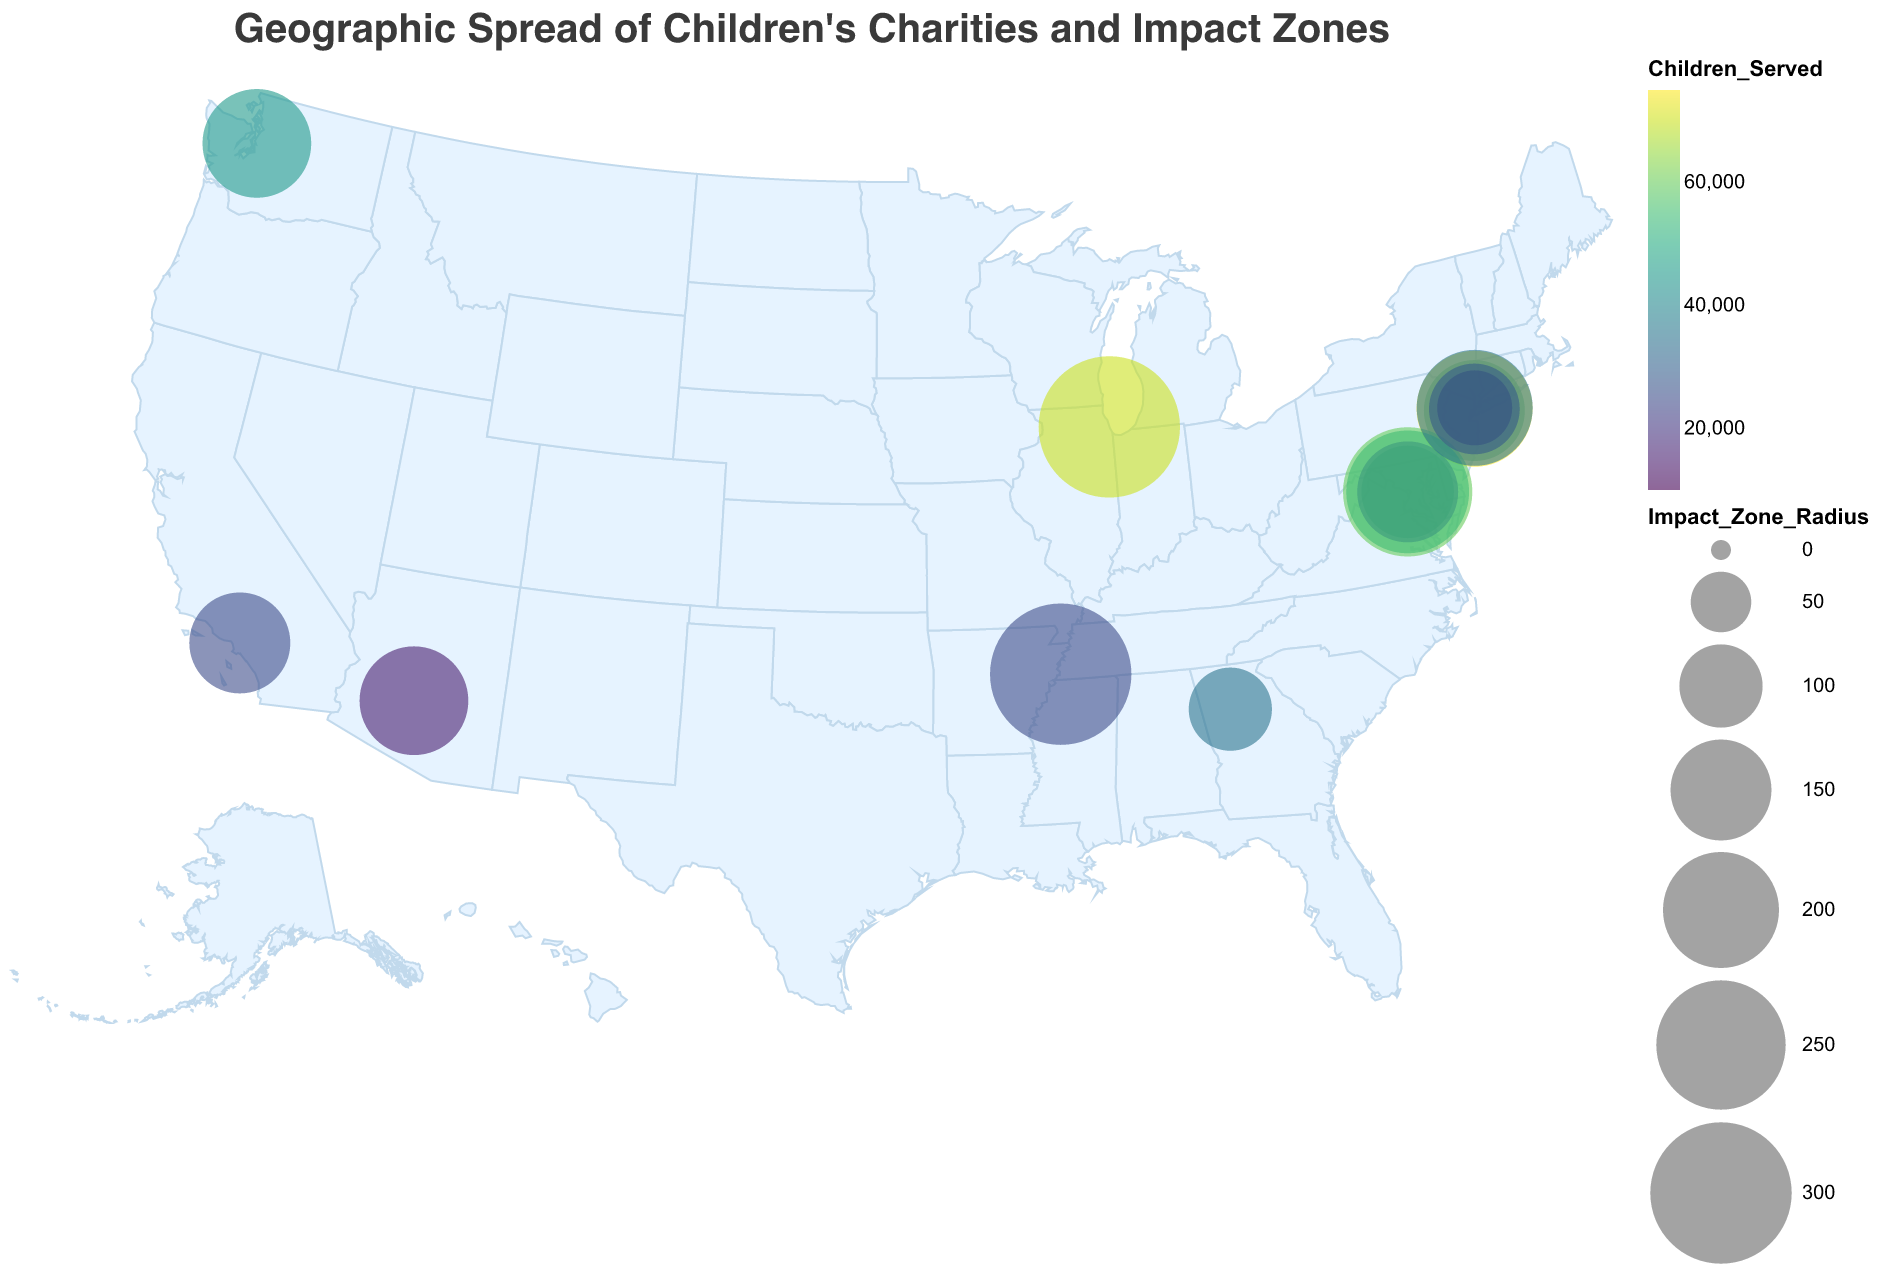What is the title of the figure? The title of an image is typically displayed at the top. Here, it reads "Geographic Spread of Children's Charities and Impact Zones."
Answer: Geographic Spread of Children's Charities and Impact Zones How many children's charities are displayed on the map? By counting the distinct circles on the map, each representing one charity, we find there are 15 in total.
Answer: 15 Which charity serves the most children and how many do they serve? Referring to the color scale and tooltip on the map, "UNICEF USA" serves the most children with a total of 75,000 served.
Answer: UNICEF USA, 75,000 Which charity has the largest impact zone radius and where is it located? By comparing the sizes of the circles, "St. Jude Children's Research Hospital" has the largest radius of 300. It is located in Memphis, TN (Latitude 35.1495, Longitude -90.0490).
Answer: St. Jude Children's Research Hospital, Memphis, TN What is the combined number of children served by the charities located in Washington, D.C.? Adding up the children served by charities in Washington, D.C. (Children's Defense Fund: 40,000; First Book: 60,000; KaBOOM!: 30,000; Reading Is Fundamental: 55,000), the total is 185,000.
Answer: 185,000 Which charity has the smallest impact zone radius and how many children does it serve? The tooltip shows that "Child Mind Institute" has the smallest impact zone radius of 80 and serves 10,000 children.
Answer: Child Mind Institute, 10,000 Between "Save the Children" and "Feeding America," which charity serves more children and by how much? "Save the Children" serves 50,000 children while "Feeding America" serves 70,000 children. The difference in the number served is 20,000.
Answer: Feeding America, 20,000 Is there any charity located in both New York City (NYC) and Washington, D.C.? Checking the location coordinates, New York City has multiple charities (Save the Children, UNICEF USA, Child Mind Institute, Covenant House, Children's Health Fund) while Washington, D.C. has several others (Children's Defense Fund, First Book, KaBOOM!, Reading Is Fundamental). No charity is listed in both locations.
Answer: No Which city has the highest concentration of children's charities, and how many are there? Washington, D.C. has the highest concentration, housing four charities: Children's Defense Fund, First Book, KaBOOM!, and Reading Is Fundamental.
Answer: Washington, D.C., 4 What patterns or trends can be observed regarding the geographic distribution of these charities? Many of these charities are located in major cities such as New York City, Washington, D.C., and Los Angeles. Some cities have multiple charities focused on children's services, indicating a regional hub for children's welfare. It can be inferred that these charities aim to serve areas with higher population densities to maximize their outreach.
Answer: Major cities have a higher concentration of charities 